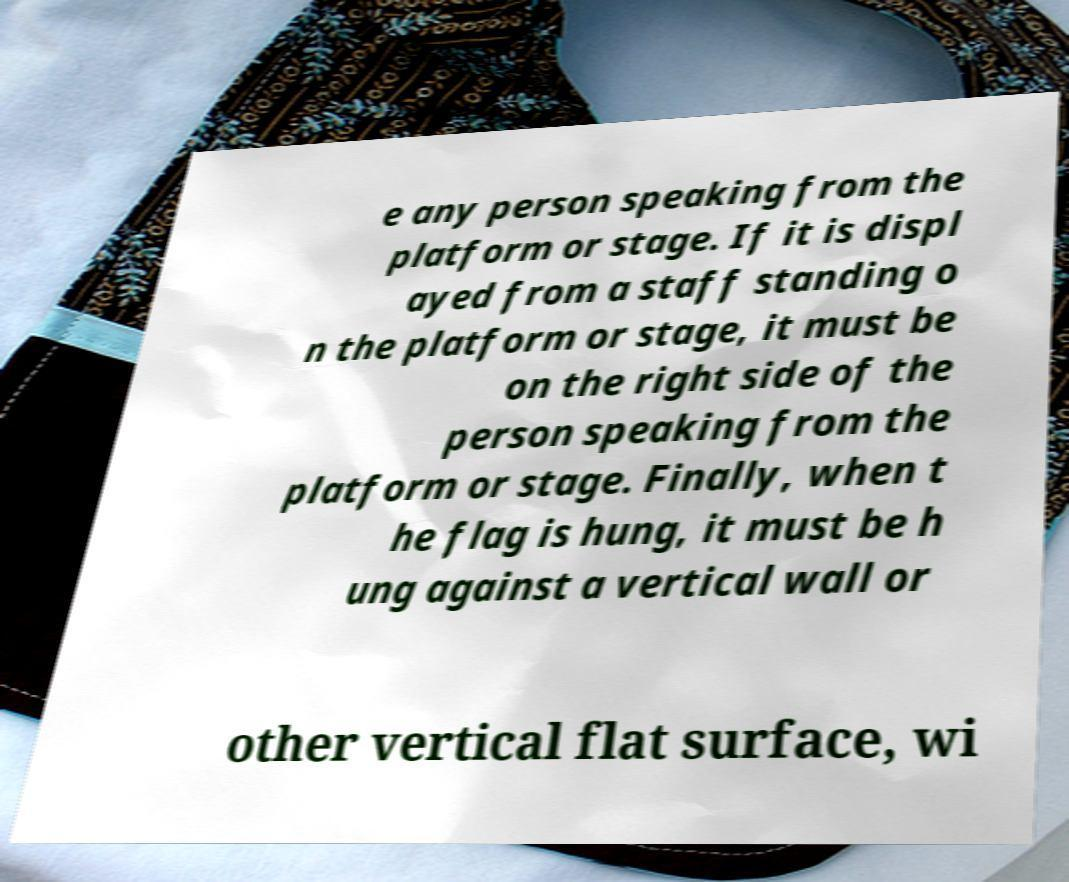Please read and relay the text visible in this image. What does it say? e any person speaking from the platform or stage. If it is displ ayed from a staff standing o n the platform or stage, it must be on the right side of the person speaking from the platform or stage. Finally, when t he flag is hung, it must be h ung against a vertical wall or other vertical flat surface, wi 